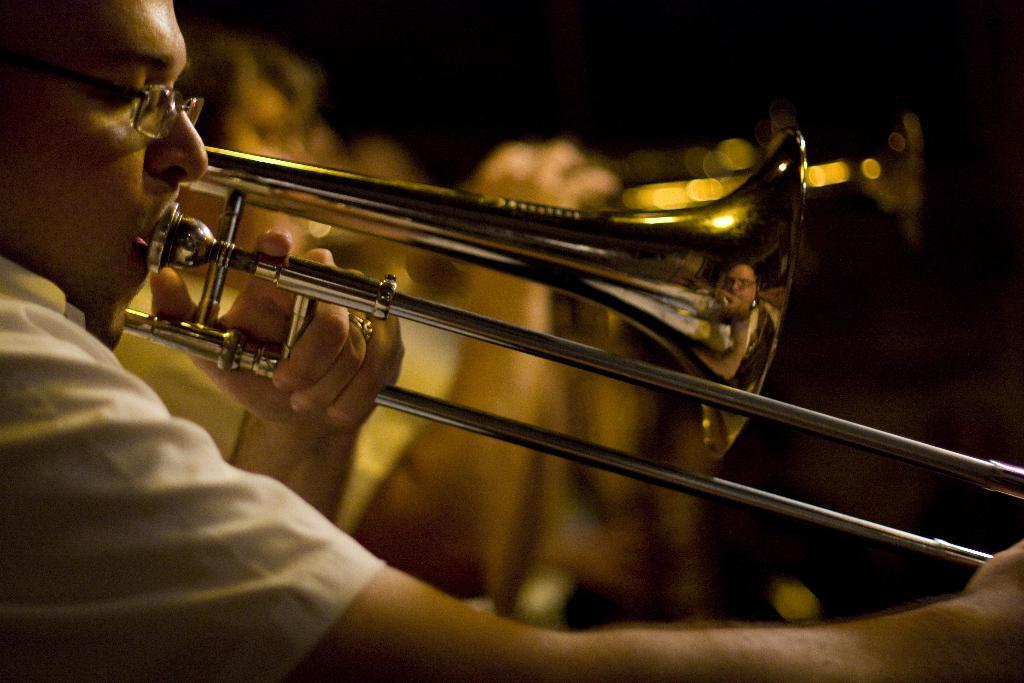What is happening in the image? There are people in the image, and they are playing musical instruments. What are the people doing while playing the instruments? The provided facts do not mention any specific actions or interactions between the people while playing the instruments. Can you see the seashore in the image? There is no mention of a seashore in the provided facts, so it cannot be determined if a seashore is present in the image. 